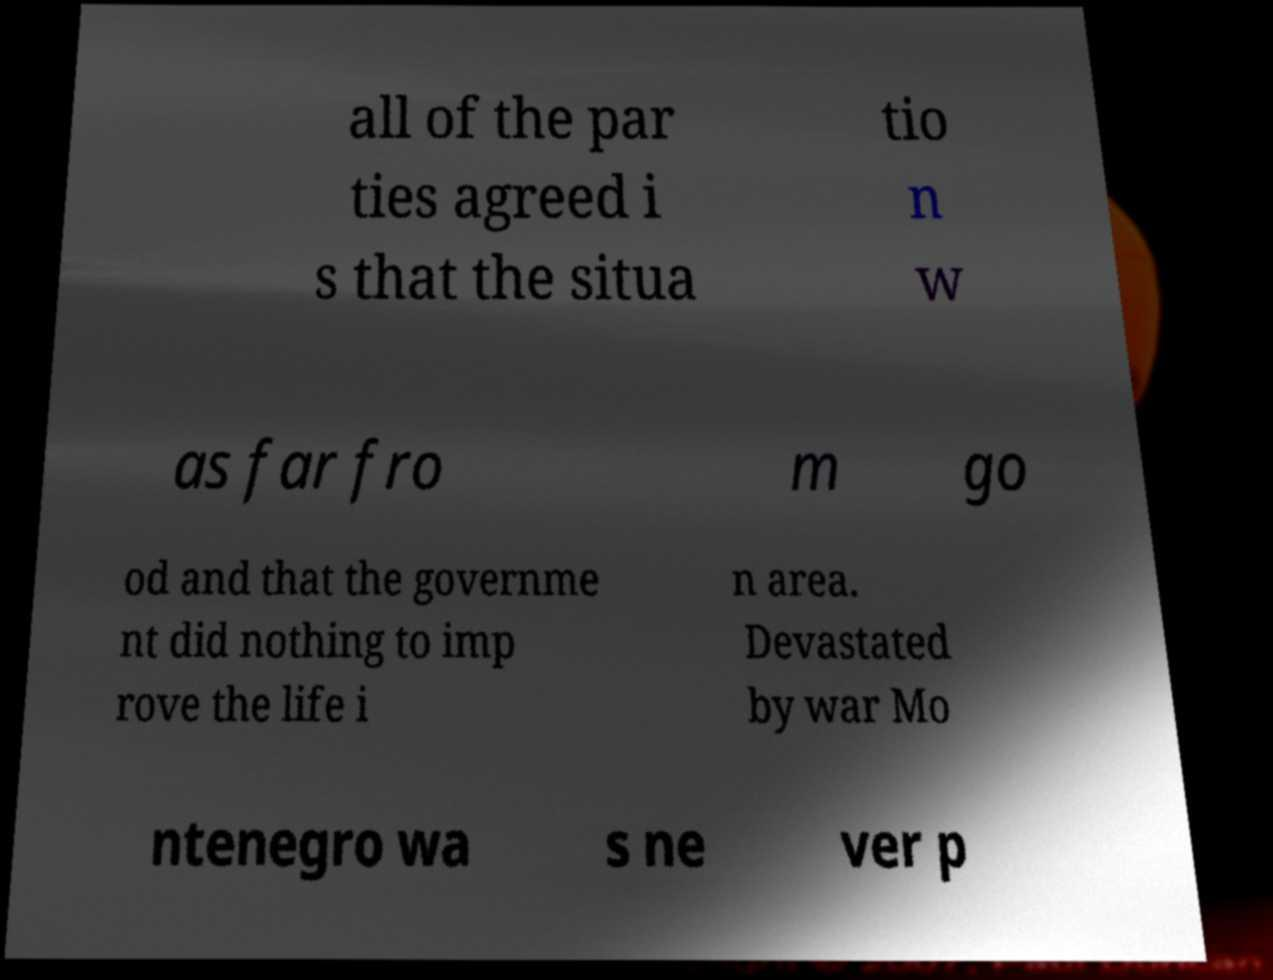Could you assist in decoding the text presented in this image and type it out clearly? all of the par ties agreed i s that the situa tio n w as far fro m go od and that the governme nt did nothing to imp rove the life i n area. Devastated by war Mo ntenegro wa s ne ver p 